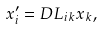<formula> <loc_0><loc_0><loc_500><loc_500>x ^ { \prime } _ { i } = D L _ { i k } x _ { k } ,</formula> 